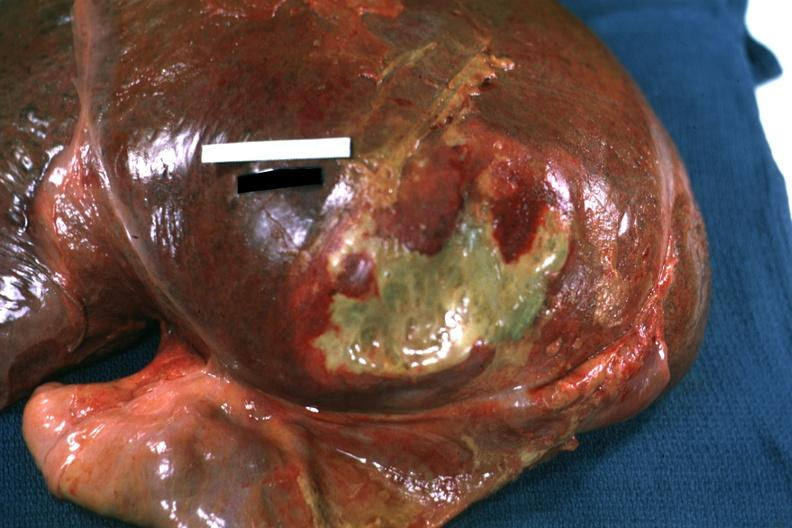s absence of palpebral fissure cleft palate present?
Answer the question using a single word or phrase. No 